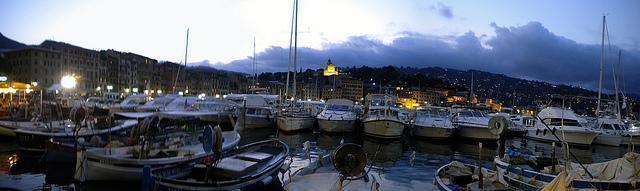How many red trucks are in the first row?
Give a very brief answer. 0. How many boats can be seen?
Give a very brief answer. 6. 